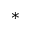<formula> <loc_0><loc_0><loc_500><loc_500>^ { * }</formula> 